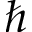Convert formula to latex. <formula><loc_0><loc_0><loc_500><loc_500>\hbar</formula> 